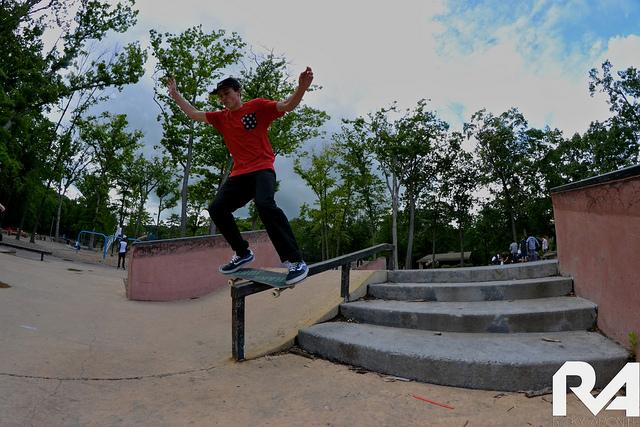What color is the t shirt?
Quick response, please. Red. What is the man skateboarding on?
Write a very short answer. Railing. What is the guy doing?
Quick response, please. Skateboarding. 